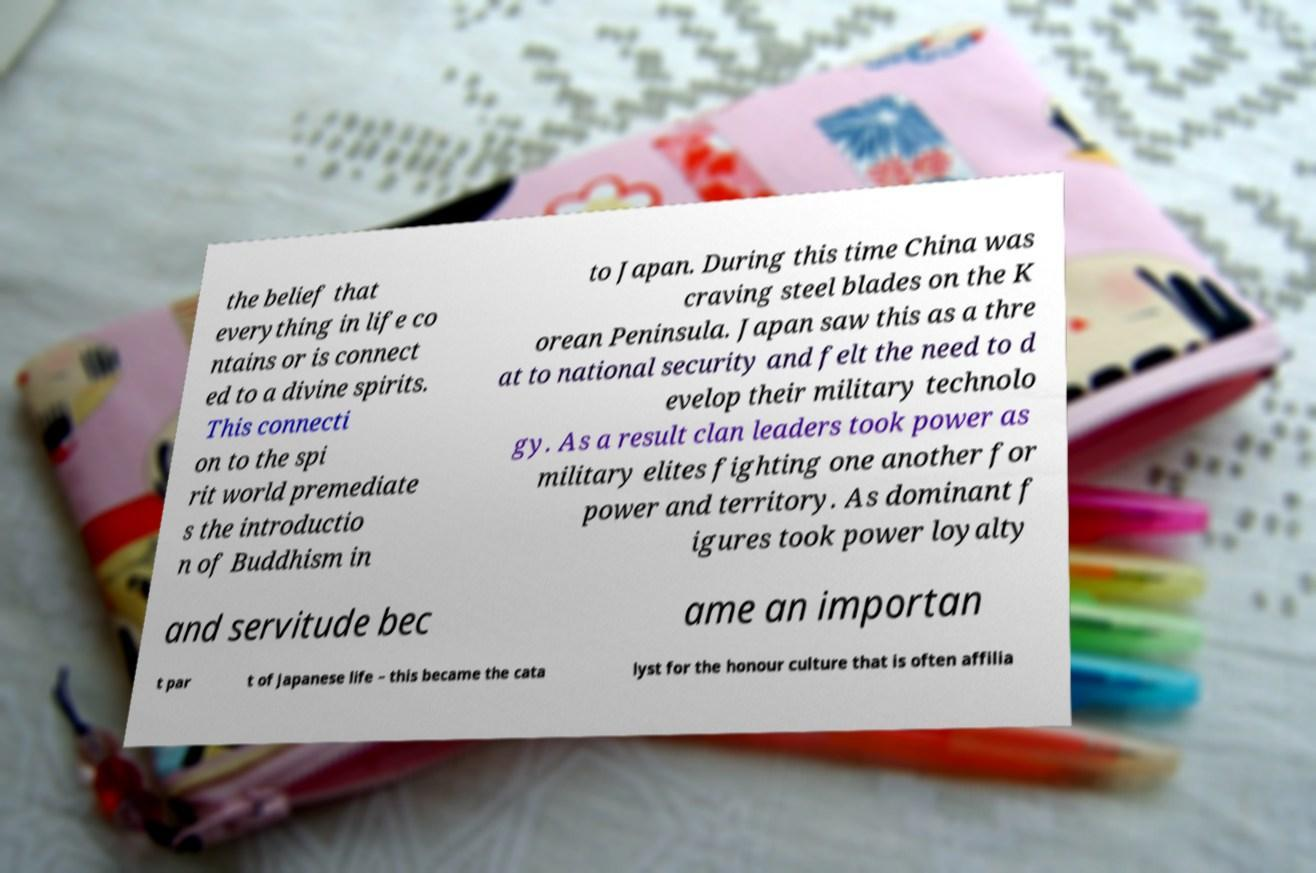For documentation purposes, I need the text within this image transcribed. Could you provide that? the belief that everything in life co ntains or is connect ed to a divine spirits. This connecti on to the spi rit world premediate s the introductio n of Buddhism in to Japan. During this time China was craving steel blades on the K orean Peninsula. Japan saw this as a thre at to national security and felt the need to d evelop their military technolo gy. As a result clan leaders took power as military elites fighting one another for power and territory. As dominant f igures took power loyalty and servitude bec ame an importan t par t of Japanese life – this became the cata lyst for the honour culture that is often affilia 